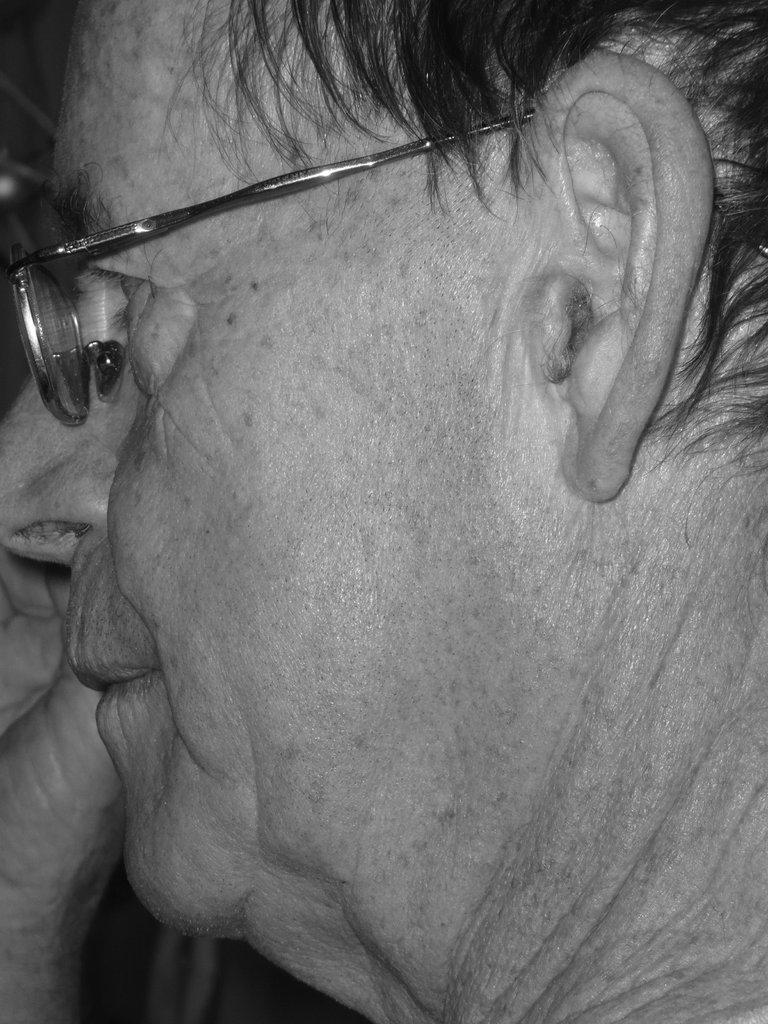Who is the main subject in the picture? The main subject in the picture is an old man. What is the old man wearing in the picture? The old man is wearing spectacles in the picture. What facial features of the old man are visible in the picture? The ear, eye, nose, and mouth of the man are visible in the picture. What is the color scheme of the picture? The picture is black and white. What does the old man's mother say in the picture? There is no dialogue or speech depicted in the picture, so it is not possible to determine what the old man's mother might say. 